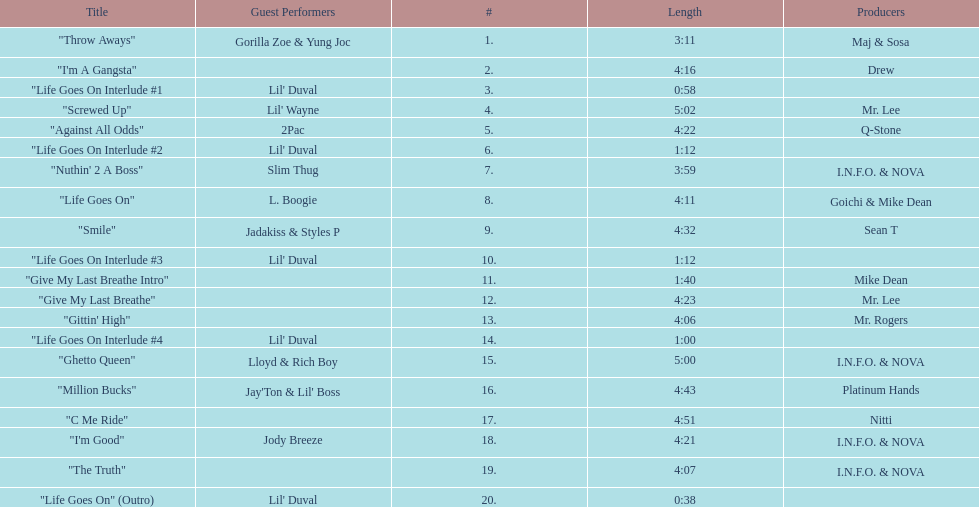Which producers produced the majority of songs on this record? I.N.F.O. & NOVA. 